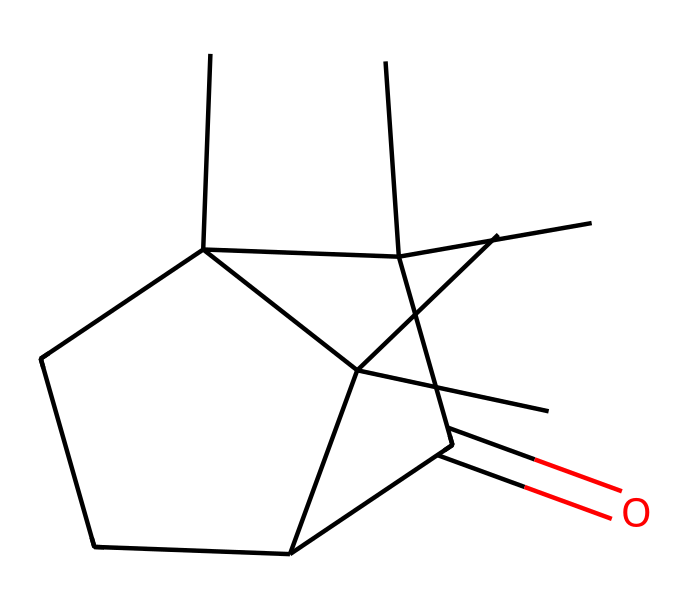What is the molecular formula of camphor? To determine the molecular formula, count the number of carbon (C), hydrogen (H), and oxygen (O) atoms in the structure represented by the SMILES. There are 10 carbon atoms, 16 hydrogen atoms, and 1 oxygen atom. Thus, the molecular formula is C10H16O.
Answer: C10H16O How many rings are present in the structure of camphor? By visualizing the chemical structure, identify the cyclic portions. There are two distinct ring structures in camphor. Both are part of the larger bicyclic framework.
Answer: 2 What characteristic functional group defines camphor as a ketone? A ketone is defined by the presence of a carbonyl group (C=O) where the carbonyl carbon is attached to two other carbon atoms. In camphor, this can be identified at the carbonyl carbon adjacent to various carbons in the rings.
Answer: carbonyl group What is the hybridization state of the carbonyl carbon in camphor? The carbonyl carbon in the ketone group has one double bond with oxygen and two single bonds with carbon, leading to a trigonal planar arrangement consistent with sp2 hybridization.
Answer: sp2 How does the structure of camphor contribute to its smell? The distinct smell of camphor arises from the presence of the ketone functional group and the specific arrangement of its carbon rings. The carbonyl group is particularly responsible for the characteristic odor, which is a feature of many small ketones.
Answer: ketone functional group What is the total number of hydrogen atoms directly connected to the ring carbons in camphor? By examining the structure, count the hydrogen atoms that are directly attached to the carbons in the ring portions. Each carbon in the ring typically bonds with hydrogen unless it is already bonded to another carbon or the carbonyl oxygen. There are 16 hydrogen atoms total, but only some are connected to ring carbons specifically, which needs isolation to ascertain the specific count directly from rings.
Answer: 10 